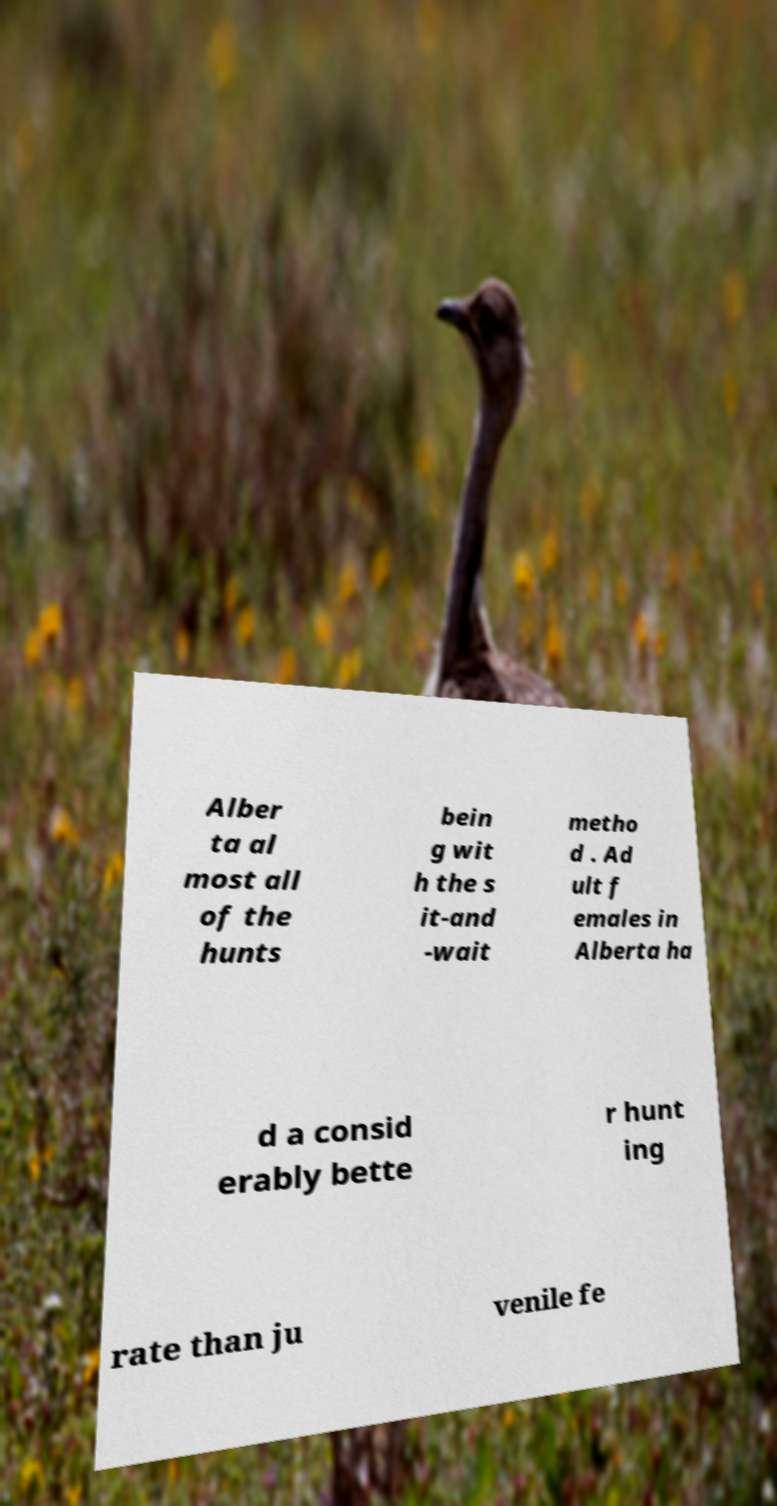What messages or text are displayed in this image? I need them in a readable, typed format. Alber ta al most all of the hunts bein g wit h the s it-and -wait metho d . Ad ult f emales in Alberta ha d a consid erably bette r hunt ing rate than ju venile fe 